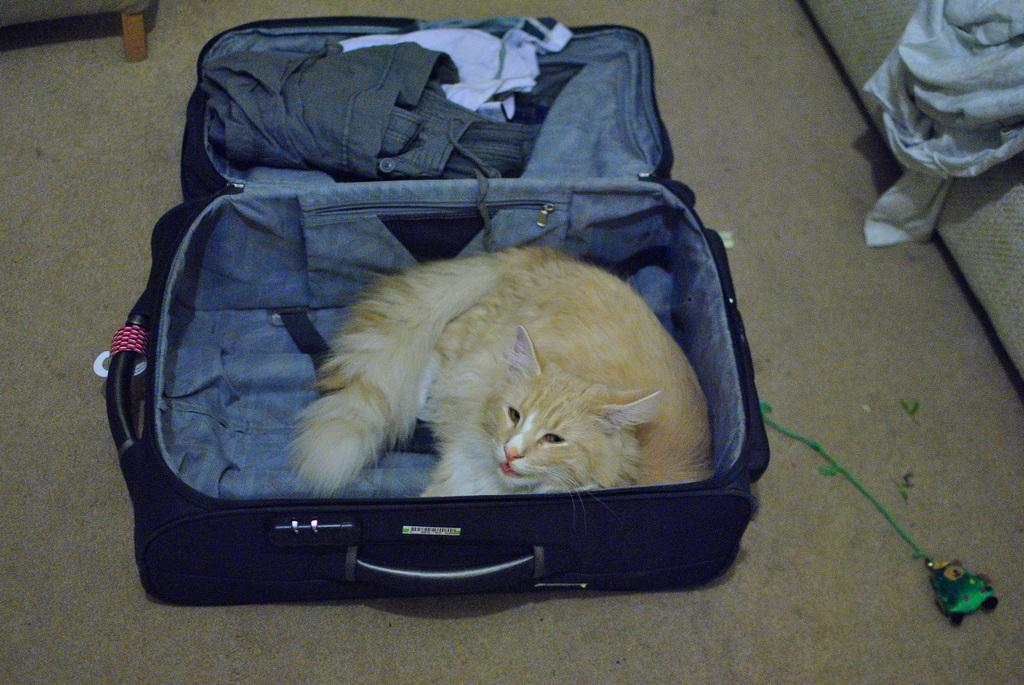In one or two sentences, can you explain what this image depicts? In the center we can see the suitcase. In suitcase we can see the cat and some clothes. 